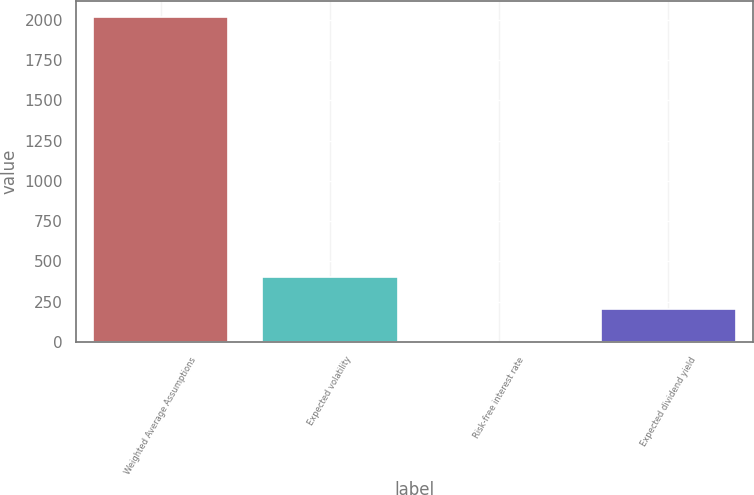<chart> <loc_0><loc_0><loc_500><loc_500><bar_chart><fcel>Weighted Average Assumptions<fcel>Expected volatility<fcel>Risk-free interest rate<fcel>Expected dividend yield<nl><fcel>2016<fcel>404.26<fcel>1.32<fcel>202.79<nl></chart> 